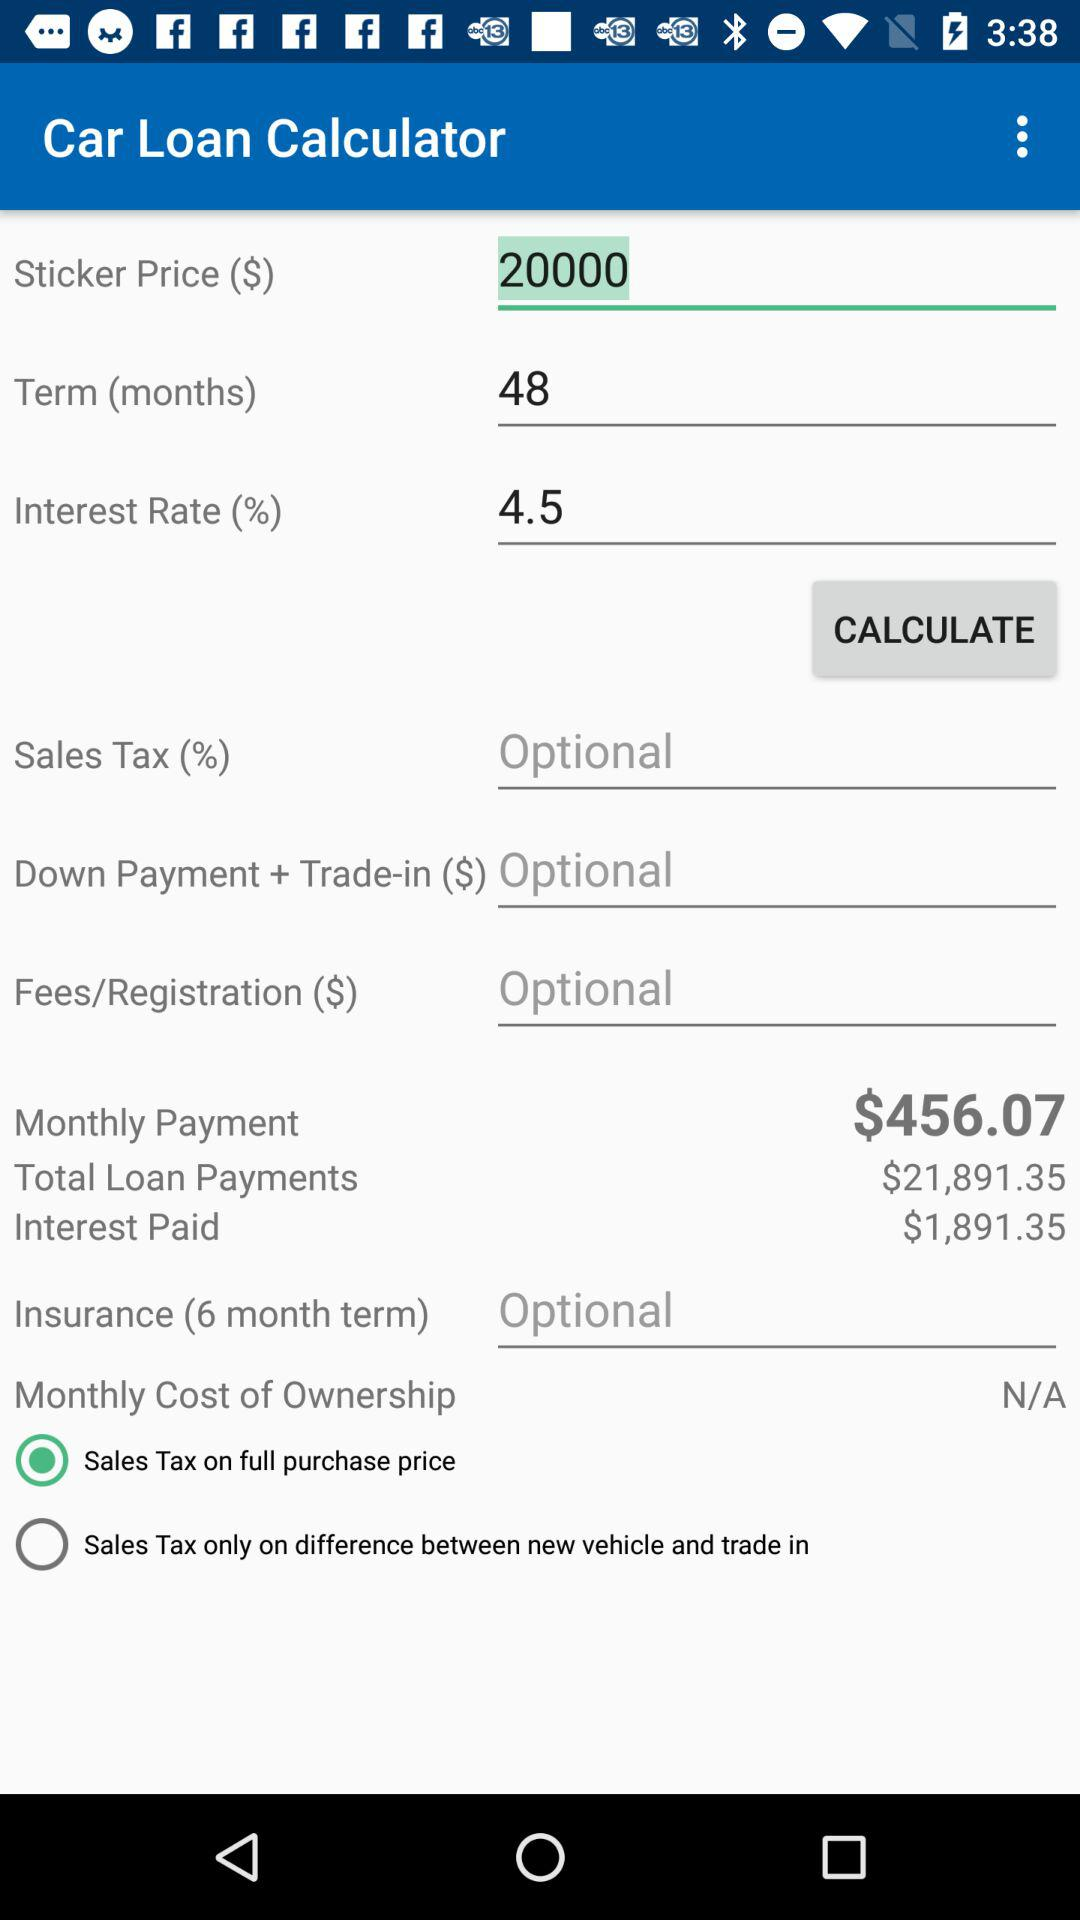What is the interest rate? The interest rate is 4.5. 